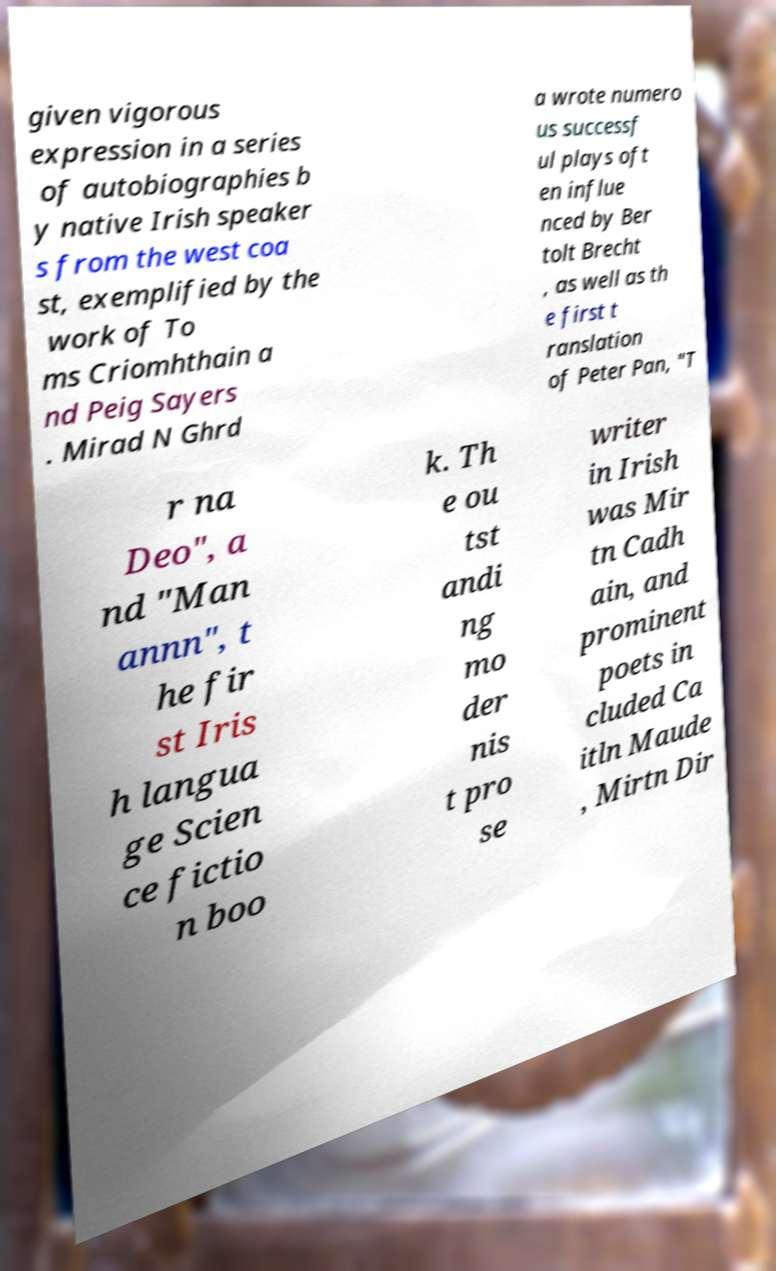Please identify and transcribe the text found in this image. given vigorous expression in a series of autobiographies b y native Irish speaker s from the west coa st, exemplified by the work of To ms Criomhthain a nd Peig Sayers . Mirad N Ghrd a wrote numero us successf ul plays oft en influe nced by Ber tolt Brecht , as well as th e first t ranslation of Peter Pan, "T r na Deo", a nd "Man annn", t he fir st Iris h langua ge Scien ce fictio n boo k. Th e ou tst andi ng mo der nis t pro se writer in Irish was Mir tn Cadh ain, and prominent poets in cluded Ca itln Maude , Mirtn Dir 